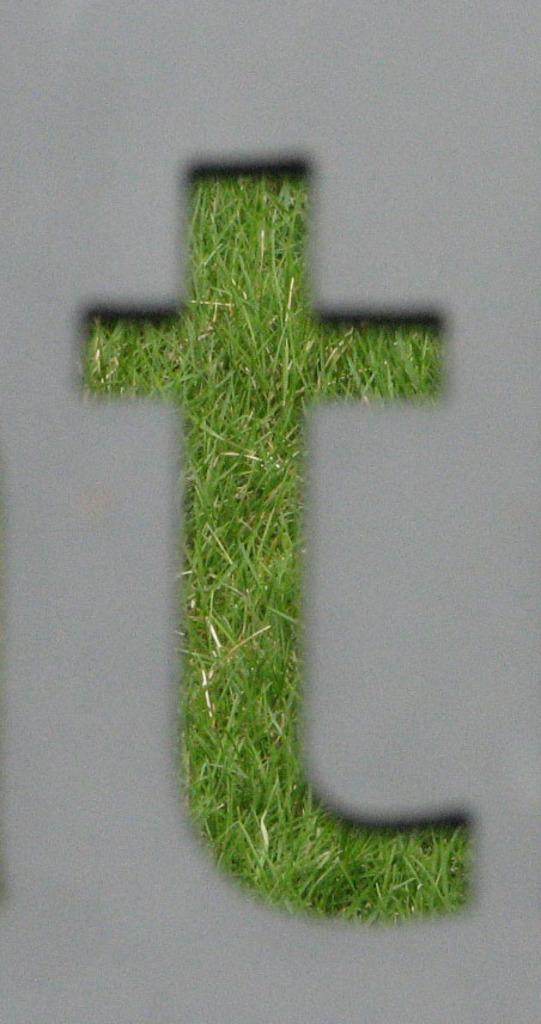What is depicted in the image? There is an alphabet in the image. What type of surface is visible in the image? There is grass in the image. What color is the background of the image? The background of the image is white. Is there any smoke coming from the alphabet in the image? No, there is no smoke present in the image. 